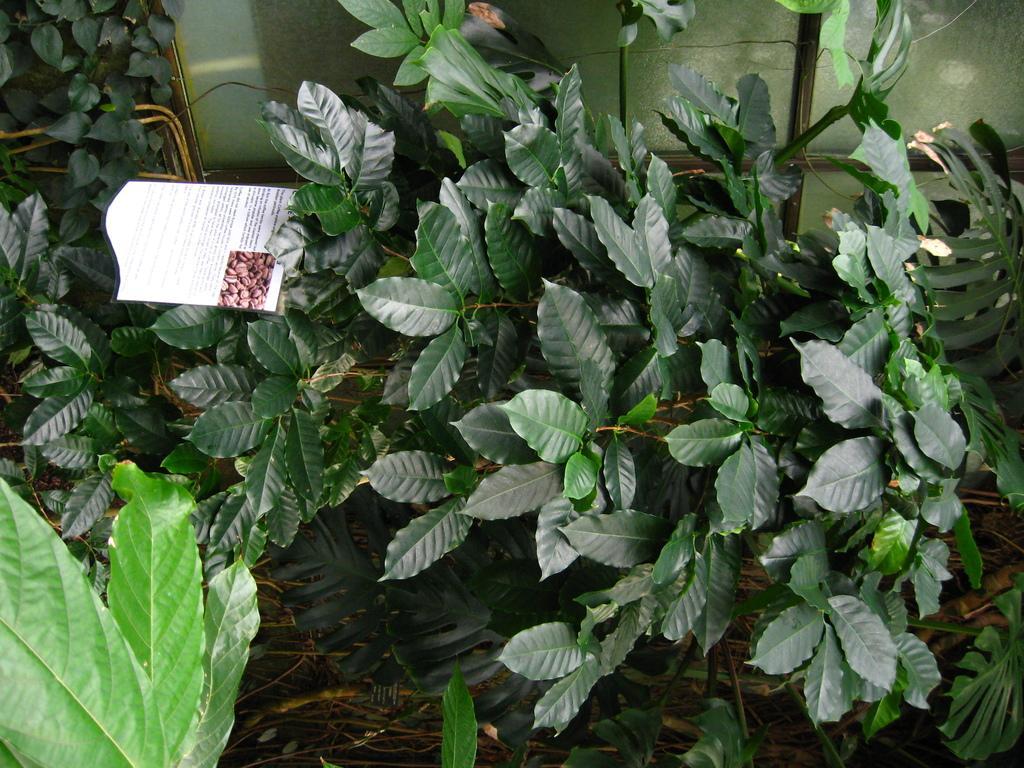Please provide a concise description of this image. In this image we can see leaves and an information card. 